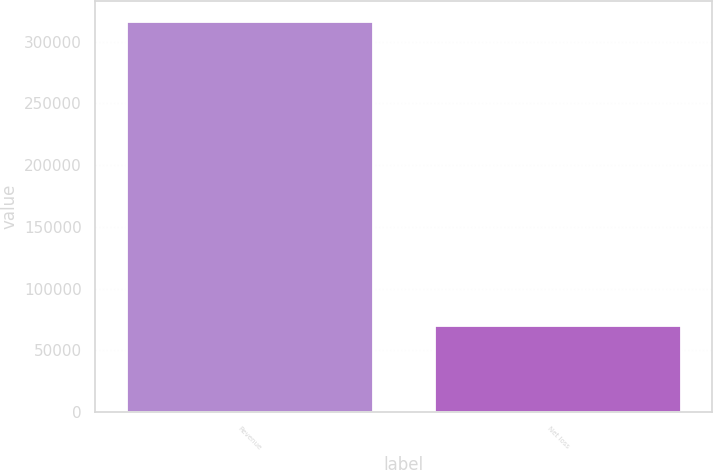<chart> <loc_0><loc_0><loc_500><loc_500><bar_chart><fcel>Revenue<fcel>Net loss<nl><fcel>316933<fcel>70200<nl></chart> 